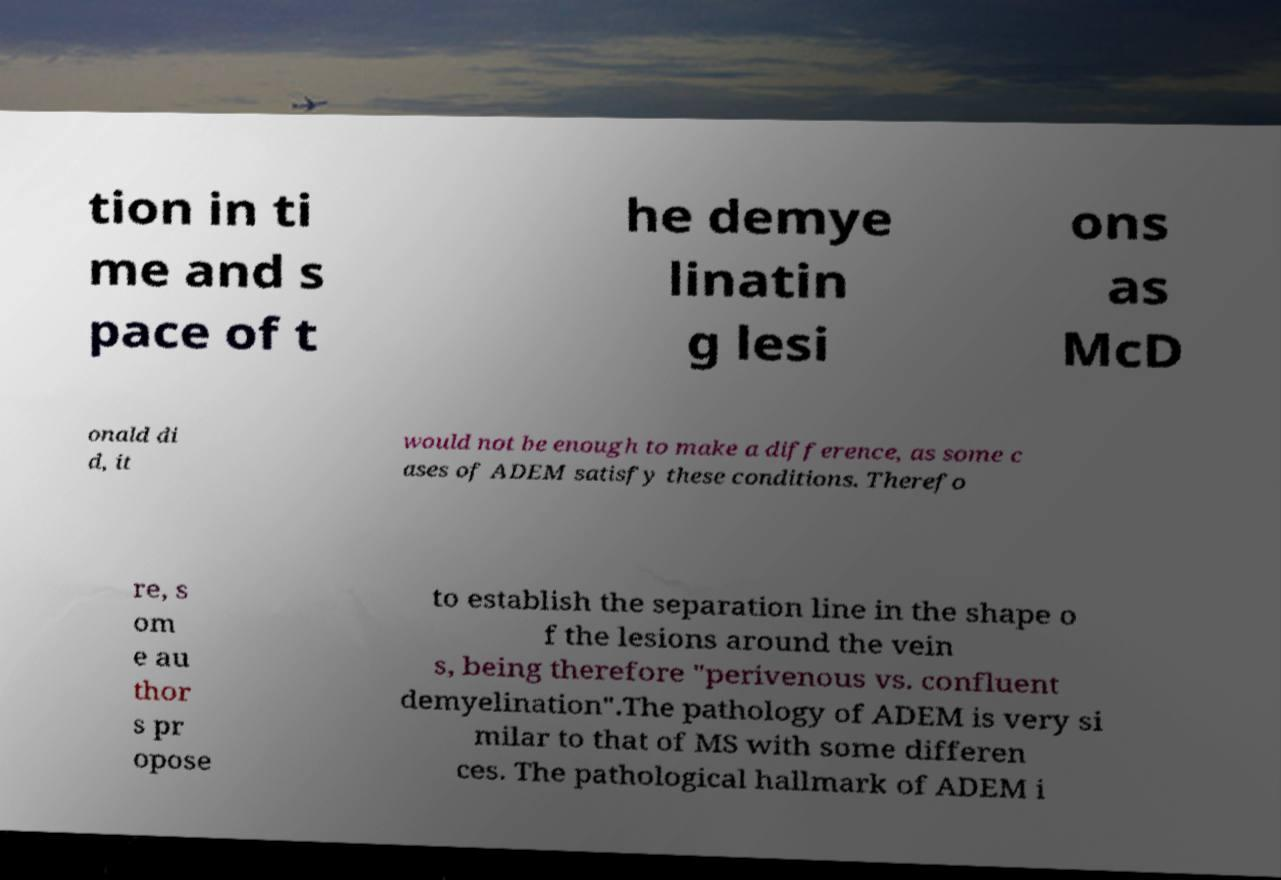Could you extract and type out the text from this image? tion in ti me and s pace of t he demye linatin g lesi ons as McD onald di d, it would not be enough to make a difference, as some c ases of ADEM satisfy these conditions. Therefo re, s om e au thor s pr opose to establish the separation line in the shape o f the lesions around the vein s, being therefore "perivenous vs. confluent demyelination".The pathology of ADEM is very si milar to that of MS with some differen ces. The pathological hallmark of ADEM i 